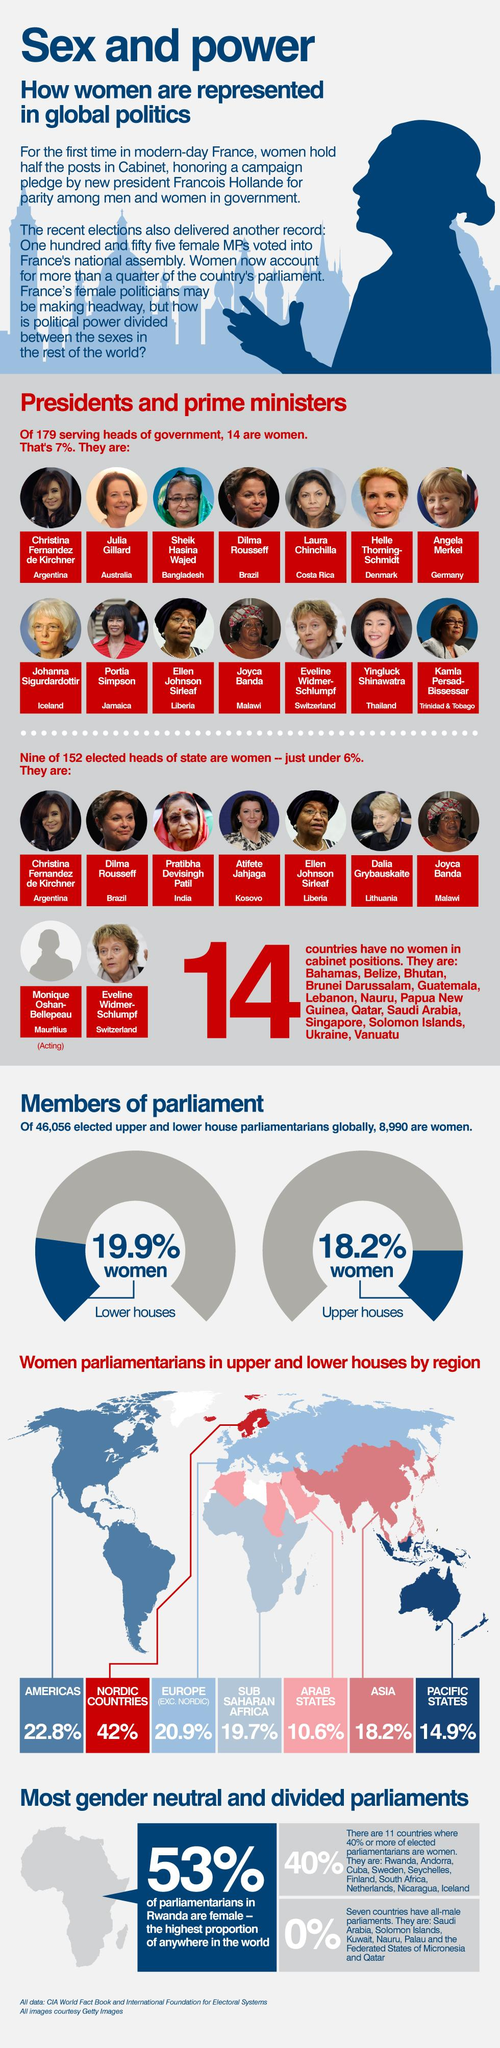Outline some significant characteristics in this image. According to recent data, Rwanda, Andorra, and Cuba are the countries with the highest number of women parliamentarians. Sheikh Hasina Wajed was a woman leader in Bangladesh. Sub-Saharan Africa has a higher percentage of women parliamentarians than the Pacific States and Arab States. Women parliamentarians in the Pacific States comprise 14.9% of the total number of parliamentarians in the region. According to the latest statistics, only 19.9% of the parliamentarians in the lower house are women. 